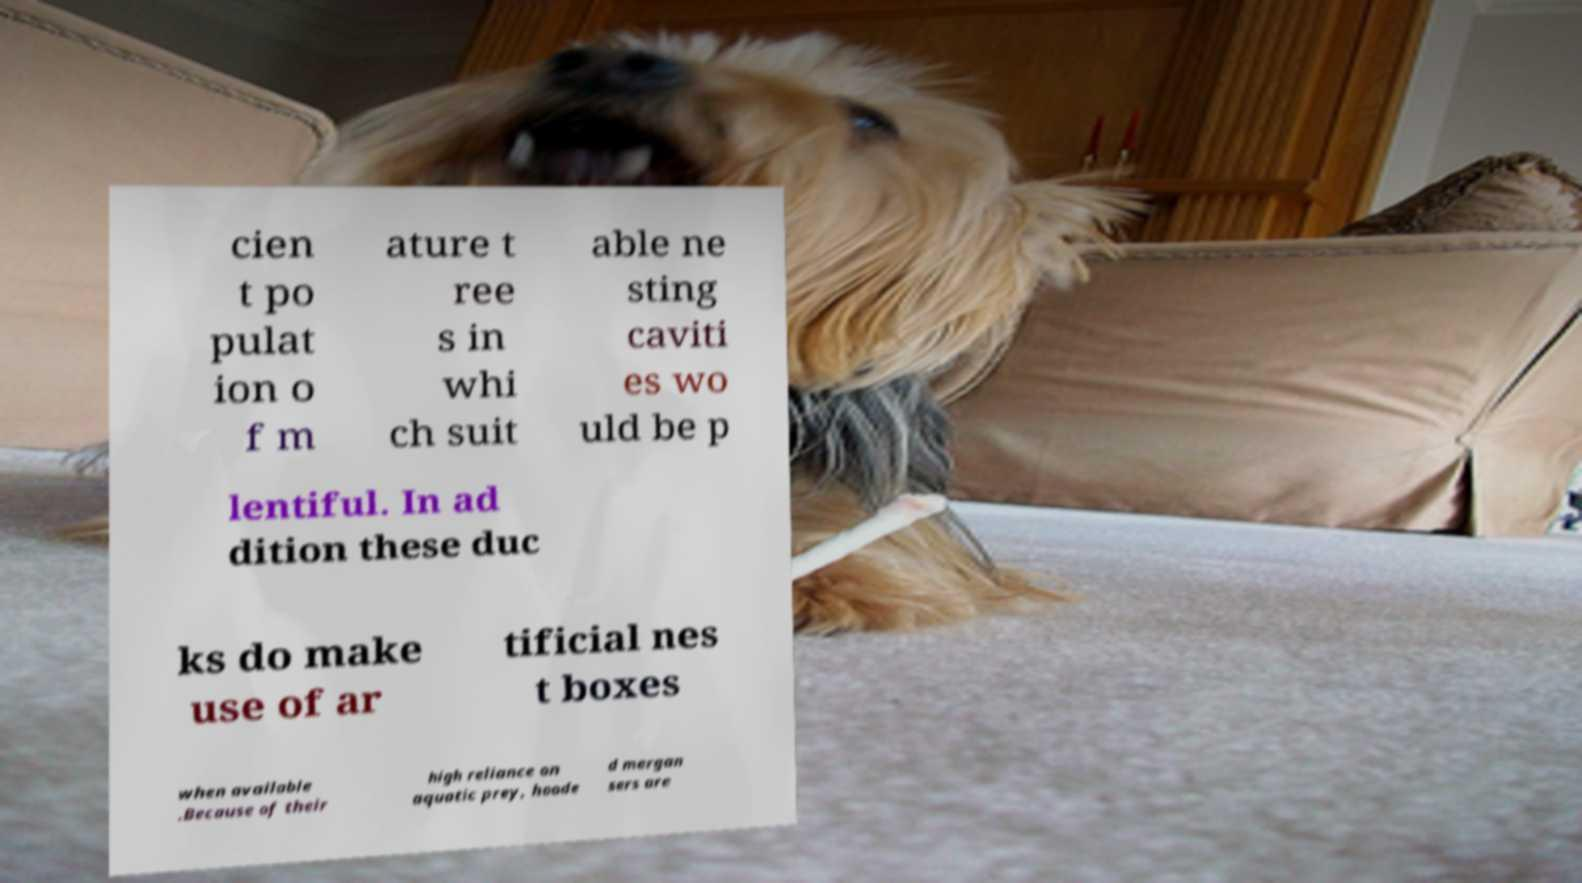Can you accurately transcribe the text from the provided image for me? cien t po pulat ion o f m ature t ree s in whi ch suit able ne sting caviti es wo uld be p lentiful. In ad dition these duc ks do make use of ar tificial nes t boxes when available .Because of their high reliance on aquatic prey, hoode d mergan sers are 